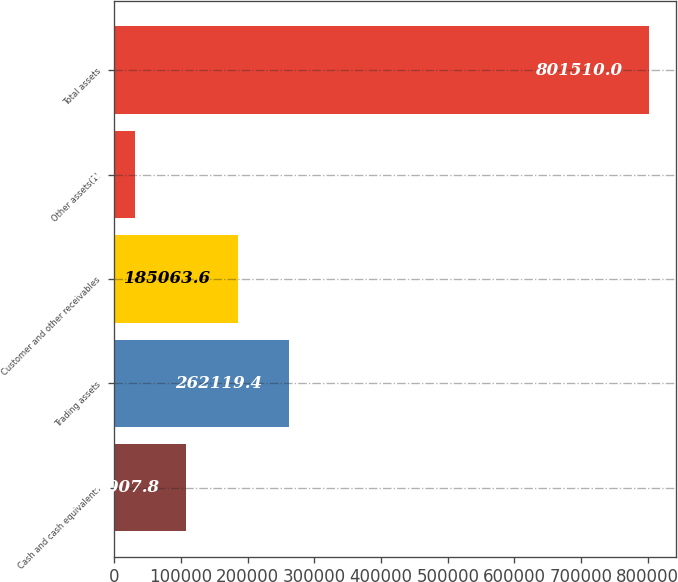Convert chart. <chart><loc_0><loc_0><loc_500><loc_500><bar_chart><fcel>Cash and cash equivalents<fcel>Trading assets<fcel>Customer and other receivables<fcel>Other assets(1)<fcel>Total assets<nl><fcel>108008<fcel>262119<fcel>185064<fcel>30952<fcel>801510<nl></chart> 